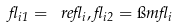Convert formula to latex. <formula><loc_0><loc_0><loc_500><loc_500>\gamma _ { i 1 } = \ r e \gamma _ { i } , \gamma _ { i 2 } = \i m \gamma _ { i }</formula> 